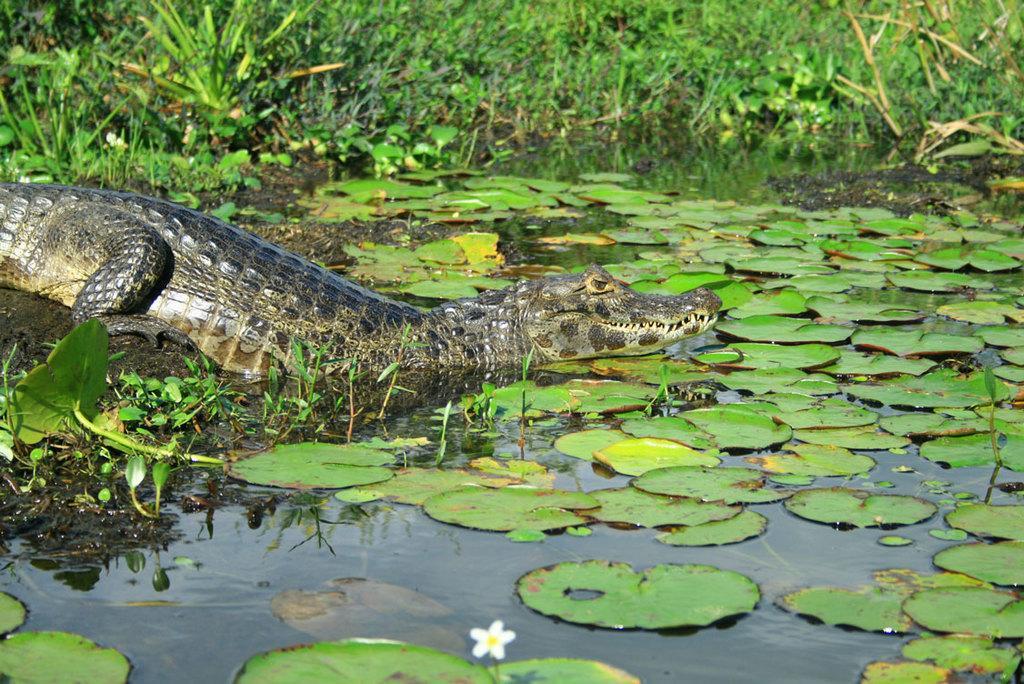Please provide a concise description of this image. In this image I can see water in the front and on it I can see number of green colour leaves. On the left side of this image I can see a crocodile and in the background I can see grass. I can also see a white colour flower on the bottom side of this image. 